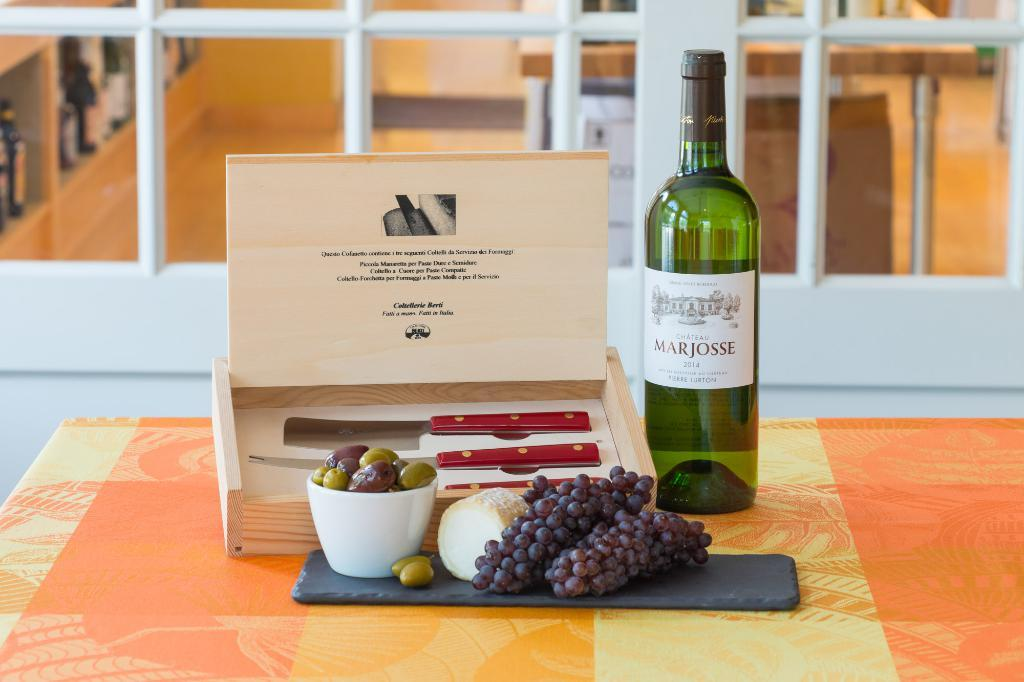<image>
Render a clear and concise summary of the photo. A bottle of Chateau Marjosse next to a box of knives. 